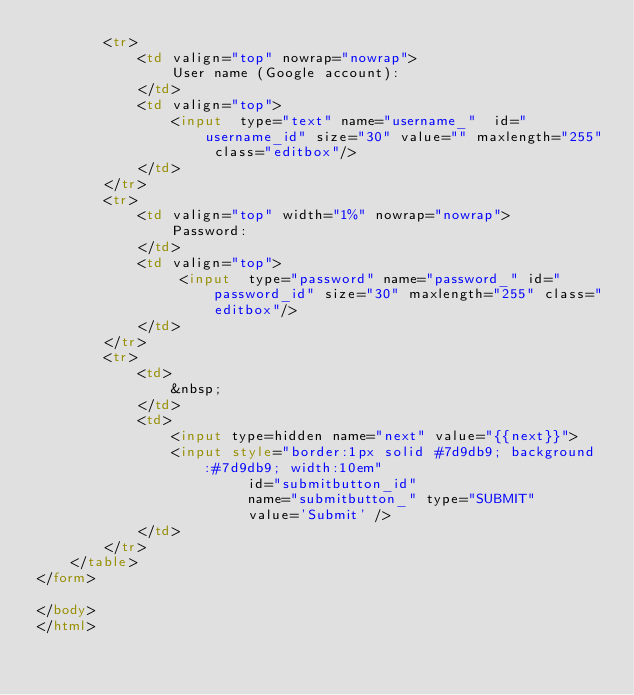Convert code to text. <code><loc_0><loc_0><loc_500><loc_500><_HTML_>        <tr>
            <td valign="top" nowrap="nowrap">
                User name (Google account):
            </td>
            <td valign="top">
                <input  type="text" name="username_"  id="username_id" size="30" value="" maxlength="255" class="editbox"/>
            </td>
        </tr>
        <tr>
            <td valign="top" width="1%" nowrap="nowrap">
                Password:
            </td>
            <td valign="top">
                 <input  type="password" name="password_" id="password_id" size="30" maxlength="255" class="editbox"/>
            </td>
        </tr>
	    <tr>
	        <td>
	            &nbsp;
	        </td>
	        <td>
                <input type=hidden name="next" value="{{next}}">
	            <input style="border:1px solid #7d9db9; background:#7d9db9; width:10em"
	                     id="submitbutton_id" 
	                     name="submitbutton_" type="SUBMIT" 
	                     value='Submit' />
	        </td>
	    </tr>
	</table>
</form>

</body>
</html>
</code> 